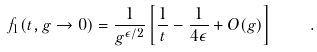<formula> <loc_0><loc_0><loc_500><loc_500>f _ { 1 } ( t , g \rightarrow 0 ) = \frac { 1 } { g ^ { \epsilon / 2 } } \left [ \frac { 1 } { t } - \frac { 1 } { 4 \epsilon } + O ( g ) \right ] \quad .</formula> 